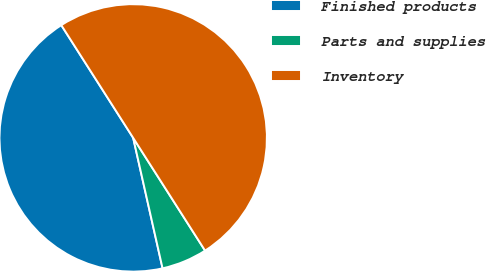Convert chart to OTSL. <chart><loc_0><loc_0><loc_500><loc_500><pie_chart><fcel>Finished products<fcel>Parts and supplies<fcel>Inventory<nl><fcel>44.49%<fcel>5.51%<fcel>50.0%<nl></chart> 